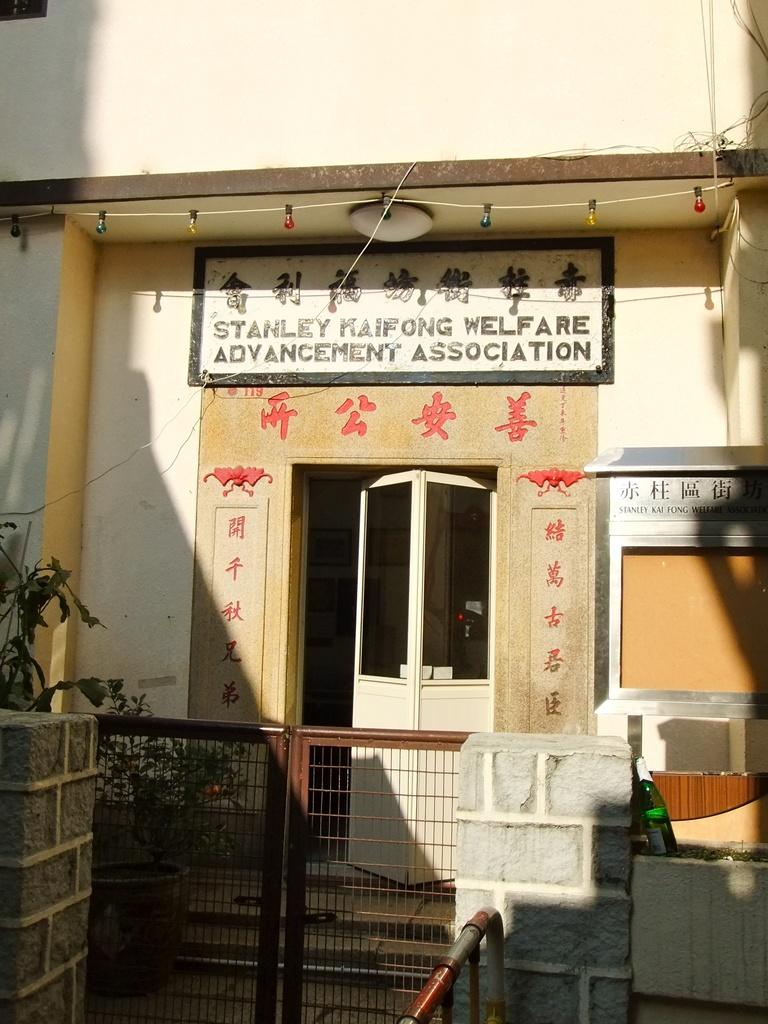What type of structure is present in the image? There is a building in the image. What feature of the building is mentioned in the facts? The building has a door. Is there any signage or identification on the building? Yes, there is a name plate on the building. How is the building secured or separated from the surrounding area? There is a gate in front of the building. What type of pest can be seen crawling on the name plate in the image? There is no pest visible on the name plate in the image. How many bags are present in the image? There is no mention of bags in the provided facts, so we cannot determine their presence or quantity in the image. 